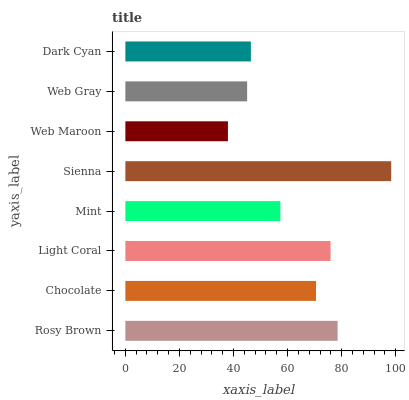Is Web Maroon the minimum?
Answer yes or no. Yes. Is Sienna the maximum?
Answer yes or no. Yes. Is Chocolate the minimum?
Answer yes or no. No. Is Chocolate the maximum?
Answer yes or no. No. Is Rosy Brown greater than Chocolate?
Answer yes or no. Yes. Is Chocolate less than Rosy Brown?
Answer yes or no. Yes. Is Chocolate greater than Rosy Brown?
Answer yes or no. No. Is Rosy Brown less than Chocolate?
Answer yes or no. No. Is Chocolate the high median?
Answer yes or no. Yes. Is Mint the low median?
Answer yes or no. Yes. Is Mint the high median?
Answer yes or no. No. Is Light Coral the low median?
Answer yes or no. No. 